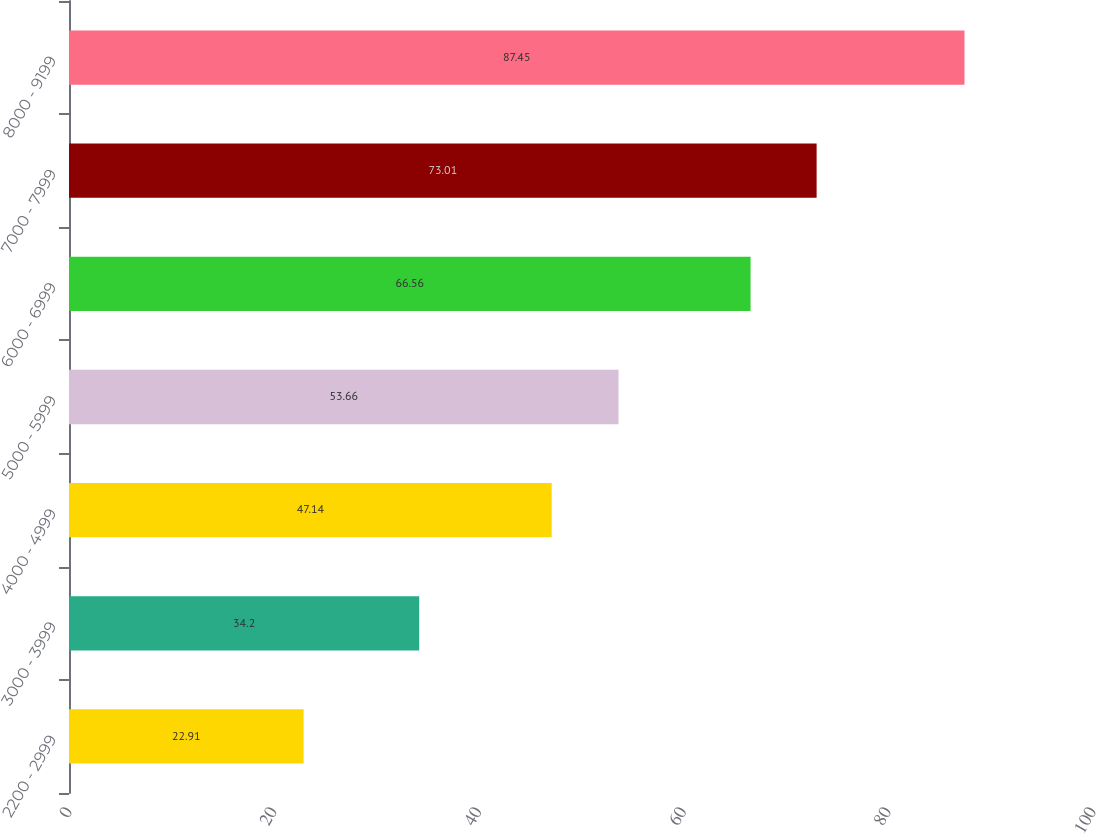Convert chart. <chart><loc_0><loc_0><loc_500><loc_500><bar_chart><fcel>2200 - 2999<fcel>3000 - 3999<fcel>4000 - 4999<fcel>5000 - 5999<fcel>6000 - 6999<fcel>7000 - 7999<fcel>8000 - 9199<nl><fcel>22.91<fcel>34.2<fcel>47.14<fcel>53.66<fcel>66.56<fcel>73.01<fcel>87.45<nl></chart> 